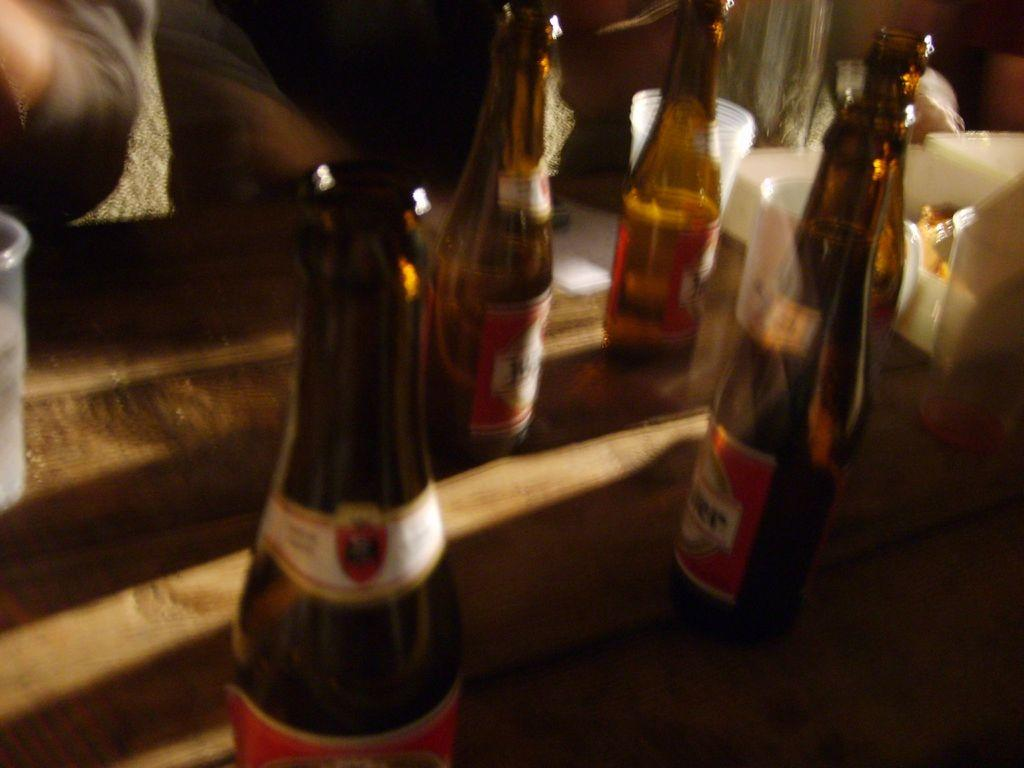What type of beverage containers are on the table in the image? There are beer bottles on the table. What type of glasses are on the table in the image? There are disposable water glasses on the table. What type of grain is stored in the basket on the table? There is no basket or grain present in the image. How many tickets are visible on the table in the image? There are no tickets present in the image. 